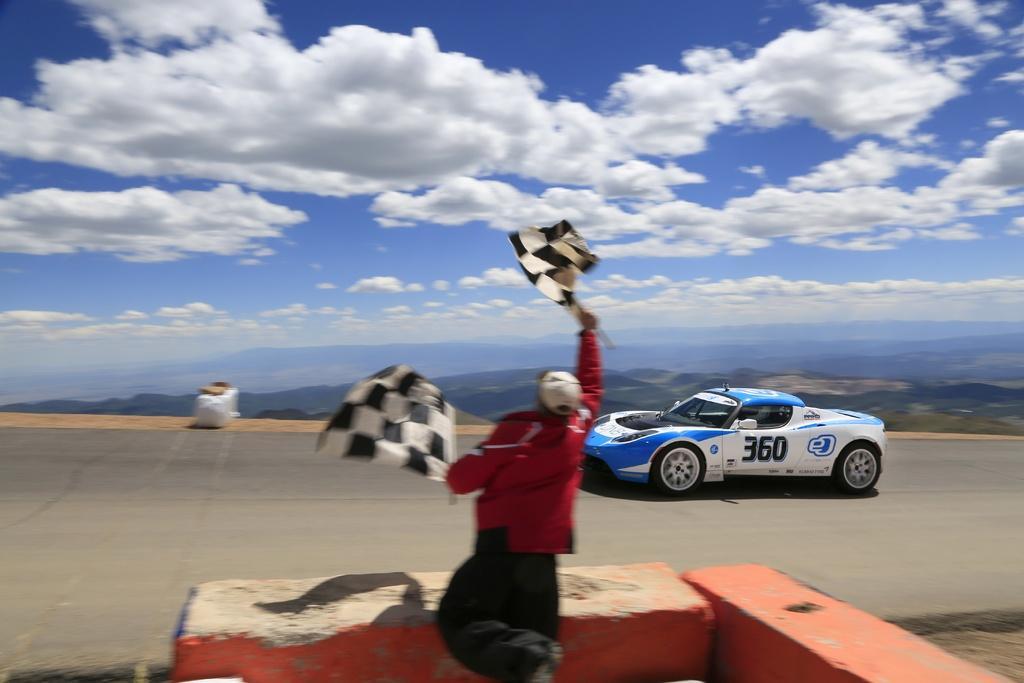In one or two sentences, can you explain what this image depicts? In this image we can see a racing car on the road and a person standing and holding flags on the road side and an objects on the other side of the road and sky with clouds on the top. 